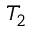<formula> <loc_0><loc_0><loc_500><loc_500>T _ { 2 }</formula> 